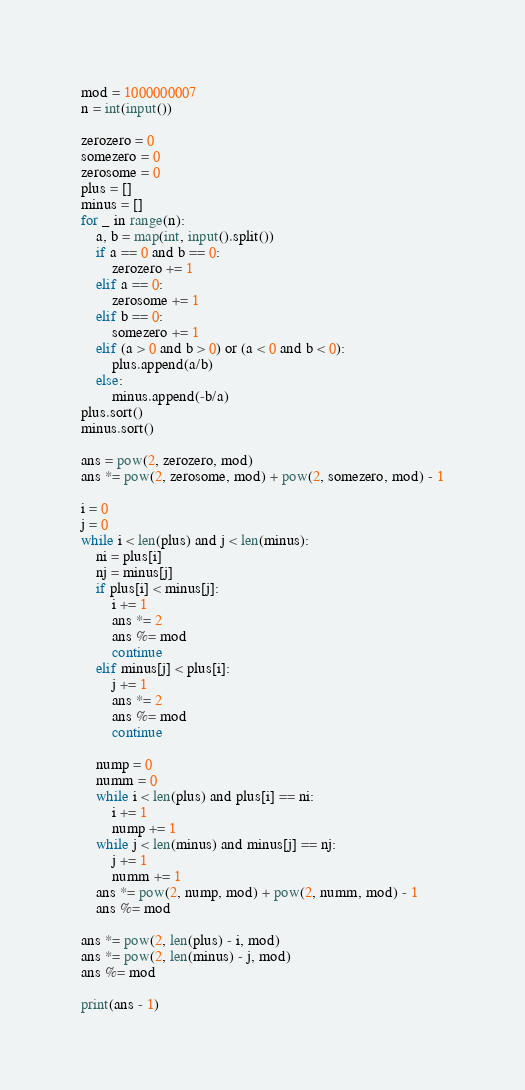Convert code to text. <code><loc_0><loc_0><loc_500><loc_500><_Python_>mod = 1000000007
n = int(input())

zerozero = 0
somezero = 0
zerosome = 0
plus = []
minus = []
for _ in range(n):
    a, b = map(int, input().split())
    if a == 0 and b == 0:
        zerozero += 1
    elif a == 0:
        zerosome += 1
    elif b == 0:
        somezero += 1
    elif (a > 0 and b > 0) or (a < 0 and b < 0):
        plus.append(a/b)
    else:
        minus.append(-b/a)
plus.sort()
minus.sort()

ans = pow(2, zerozero, mod)
ans *= pow(2, zerosome, mod) + pow(2, somezero, mod) - 1

i = 0
j = 0
while i < len(plus) and j < len(minus):
    ni = plus[i]
    nj = minus[j]
    if plus[i] < minus[j]:
        i += 1
        ans *= 2
        ans %= mod
        continue
    elif minus[j] < plus[i]:
        j += 1
        ans *= 2
        ans %= mod
        continue

    nump = 0
    numm = 0
    while i < len(plus) and plus[i] == ni:
        i += 1
        nump += 1
    while j < len(minus) and minus[j] == nj:
        j += 1
        numm += 1
    ans *= pow(2, nump, mod) + pow(2, numm, mod) - 1
    ans %= mod

ans *= pow(2, len(plus) - i, mod)
ans *= pow(2, len(minus) - j, mod)
ans %= mod

print(ans - 1)</code> 